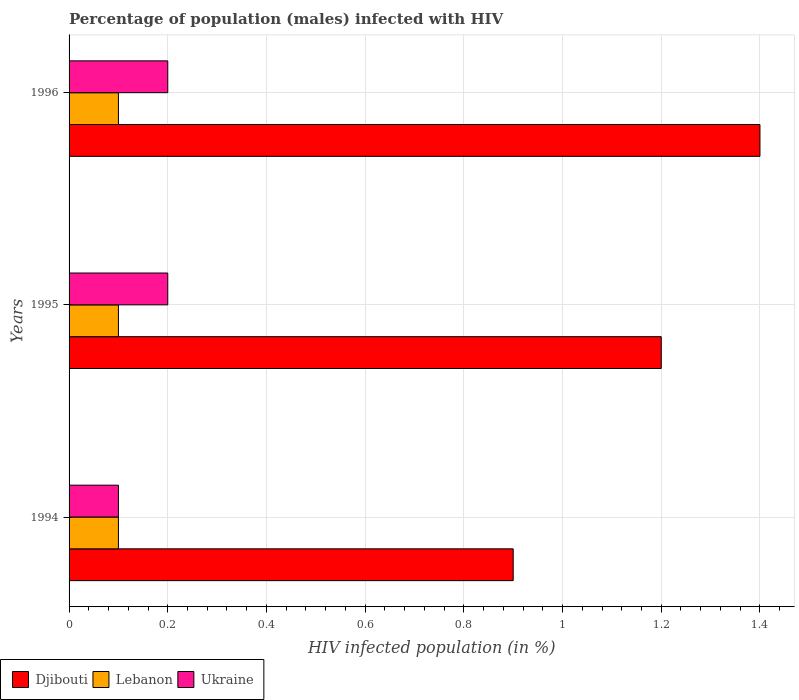How many different coloured bars are there?
Keep it short and to the point. 3. How many groups of bars are there?
Provide a succinct answer. 3. Are the number of bars per tick equal to the number of legend labels?
Your response must be concise. Yes. How many bars are there on the 3rd tick from the bottom?
Your answer should be compact. 3. What is the label of the 2nd group of bars from the top?
Your answer should be compact. 1995. In how many cases, is the number of bars for a given year not equal to the number of legend labels?
Provide a short and direct response. 0. What is the percentage of HIV infected male population in Djibouti in 1994?
Offer a terse response. 0.9. Across all years, what is the minimum percentage of HIV infected male population in Lebanon?
Offer a terse response. 0.1. In which year was the percentage of HIV infected male population in Lebanon maximum?
Provide a succinct answer. 1994. What is the total percentage of HIV infected male population in Djibouti in the graph?
Offer a very short reply. 3.5. What is the difference between the percentage of HIV infected male population in Lebanon in 1996 and the percentage of HIV infected male population in Djibouti in 1995?
Provide a short and direct response. -1.1. What is the average percentage of HIV infected male population in Lebanon per year?
Your answer should be compact. 0.1. In the year 1994, what is the difference between the percentage of HIV infected male population in Djibouti and percentage of HIV infected male population in Lebanon?
Your answer should be compact. 0.8. In how many years, is the percentage of HIV infected male population in Lebanon greater than 0.7600000000000001 %?
Your answer should be compact. 0. What is the difference between the highest and the lowest percentage of HIV infected male population in Ukraine?
Offer a very short reply. 0.1. What does the 3rd bar from the top in 1995 represents?
Your response must be concise. Djibouti. What does the 3rd bar from the bottom in 1995 represents?
Your response must be concise. Ukraine. Is it the case that in every year, the sum of the percentage of HIV infected male population in Djibouti and percentage of HIV infected male population in Ukraine is greater than the percentage of HIV infected male population in Lebanon?
Provide a succinct answer. Yes. How many years are there in the graph?
Give a very brief answer. 3. What is the difference between two consecutive major ticks on the X-axis?
Offer a terse response. 0.2. Does the graph contain any zero values?
Provide a succinct answer. No. Where does the legend appear in the graph?
Ensure brevity in your answer.  Bottom left. What is the title of the graph?
Make the answer very short. Percentage of population (males) infected with HIV. Does "Turkmenistan" appear as one of the legend labels in the graph?
Give a very brief answer. No. What is the label or title of the X-axis?
Your response must be concise. HIV infected population (in %). What is the label or title of the Y-axis?
Your answer should be compact. Years. What is the HIV infected population (in %) of Lebanon in 1994?
Ensure brevity in your answer.  0.1. What is the HIV infected population (in %) of Ukraine in 1994?
Your answer should be very brief. 0.1. What is the HIV infected population (in %) of Lebanon in 1995?
Give a very brief answer. 0.1. What is the HIV infected population (in %) of Ukraine in 1995?
Offer a terse response. 0.2. What is the HIV infected population (in %) in Djibouti in 1996?
Provide a succinct answer. 1.4. What is the HIV infected population (in %) in Lebanon in 1996?
Make the answer very short. 0.1. Across all years, what is the maximum HIV infected population (in %) in Djibouti?
Provide a succinct answer. 1.4. Across all years, what is the maximum HIV infected population (in %) of Lebanon?
Ensure brevity in your answer.  0.1. Across all years, what is the maximum HIV infected population (in %) of Ukraine?
Make the answer very short. 0.2. What is the difference between the HIV infected population (in %) in Ukraine in 1994 and that in 1995?
Provide a succinct answer. -0.1. What is the difference between the HIV infected population (in %) in Lebanon in 1994 and that in 1996?
Your answer should be compact. 0. What is the difference between the HIV infected population (in %) of Ukraine in 1994 and that in 1996?
Your answer should be compact. -0.1. What is the difference between the HIV infected population (in %) of Djibouti in 1995 and that in 1996?
Your response must be concise. -0.2. What is the difference between the HIV infected population (in %) of Lebanon in 1995 and that in 1996?
Your answer should be compact. 0. What is the difference between the HIV infected population (in %) in Djibouti in 1994 and the HIV infected population (in %) in Lebanon in 1995?
Offer a very short reply. 0.8. What is the difference between the HIV infected population (in %) in Djibouti in 1994 and the HIV infected population (in %) in Ukraine in 1996?
Give a very brief answer. 0.7. What is the difference between the HIV infected population (in %) of Lebanon in 1994 and the HIV infected population (in %) of Ukraine in 1996?
Give a very brief answer. -0.1. What is the difference between the HIV infected population (in %) of Djibouti in 1995 and the HIV infected population (in %) of Lebanon in 1996?
Make the answer very short. 1.1. What is the difference between the HIV infected population (in %) of Djibouti in 1995 and the HIV infected population (in %) of Ukraine in 1996?
Offer a very short reply. 1. What is the average HIV infected population (in %) of Lebanon per year?
Your response must be concise. 0.1. In the year 1995, what is the difference between the HIV infected population (in %) of Djibouti and HIV infected population (in %) of Lebanon?
Keep it short and to the point. 1.1. In the year 1996, what is the difference between the HIV infected population (in %) of Djibouti and HIV infected population (in %) of Ukraine?
Your answer should be very brief. 1.2. In the year 1996, what is the difference between the HIV infected population (in %) in Lebanon and HIV infected population (in %) in Ukraine?
Keep it short and to the point. -0.1. What is the ratio of the HIV infected population (in %) in Djibouti in 1994 to that in 1995?
Keep it short and to the point. 0.75. What is the ratio of the HIV infected population (in %) of Ukraine in 1994 to that in 1995?
Provide a succinct answer. 0.5. What is the ratio of the HIV infected population (in %) of Djibouti in 1994 to that in 1996?
Provide a short and direct response. 0.64. What is the ratio of the HIV infected population (in %) in Djibouti in 1995 to that in 1996?
Provide a short and direct response. 0.86. What is the ratio of the HIV infected population (in %) of Lebanon in 1995 to that in 1996?
Provide a succinct answer. 1. What is the difference between the highest and the second highest HIV infected population (in %) in Djibouti?
Your answer should be very brief. 0.2. What is the difference between the highest and the lowest HIV infected population (in %) of Djibouti?
Provide a short and direct response. 0.5. What is the difference between the highest and the lowest HIV infected population (in %) in Ukraine?
Keep it short and to the point. 0.1. 